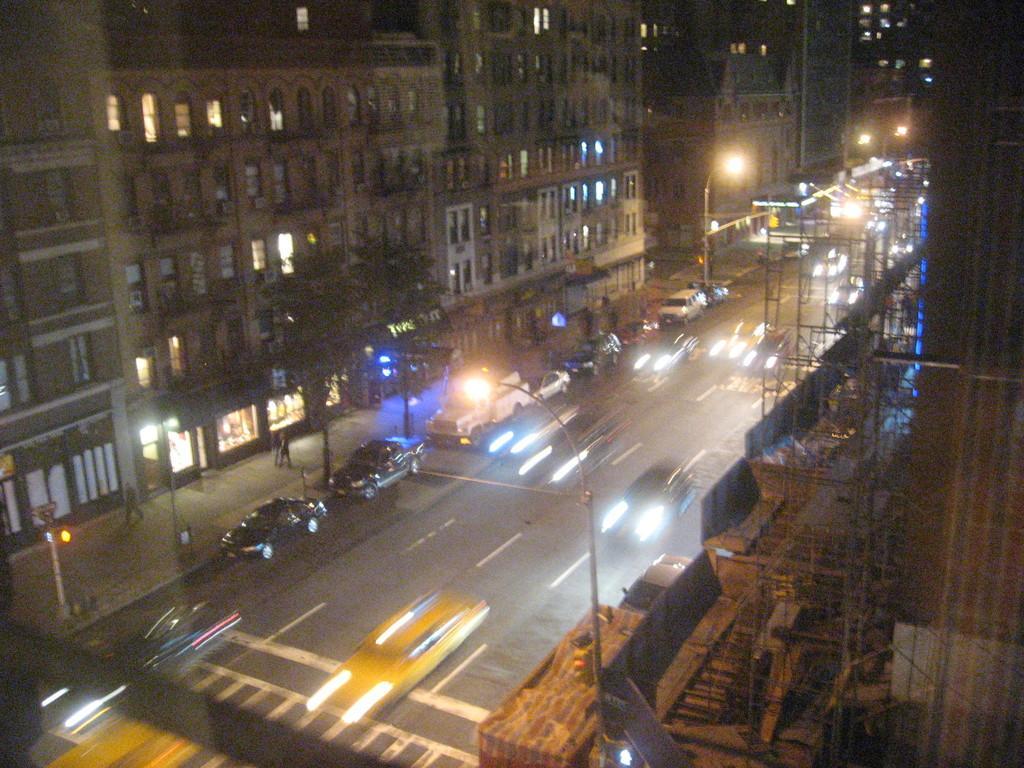In one or two sentences, can you explain what this image depicts? In the image in the center we can see few vehicles on the road. And few people were walking on the road. In the background we can see buildings,windows,poles,trees,sign boards,lights etc. 